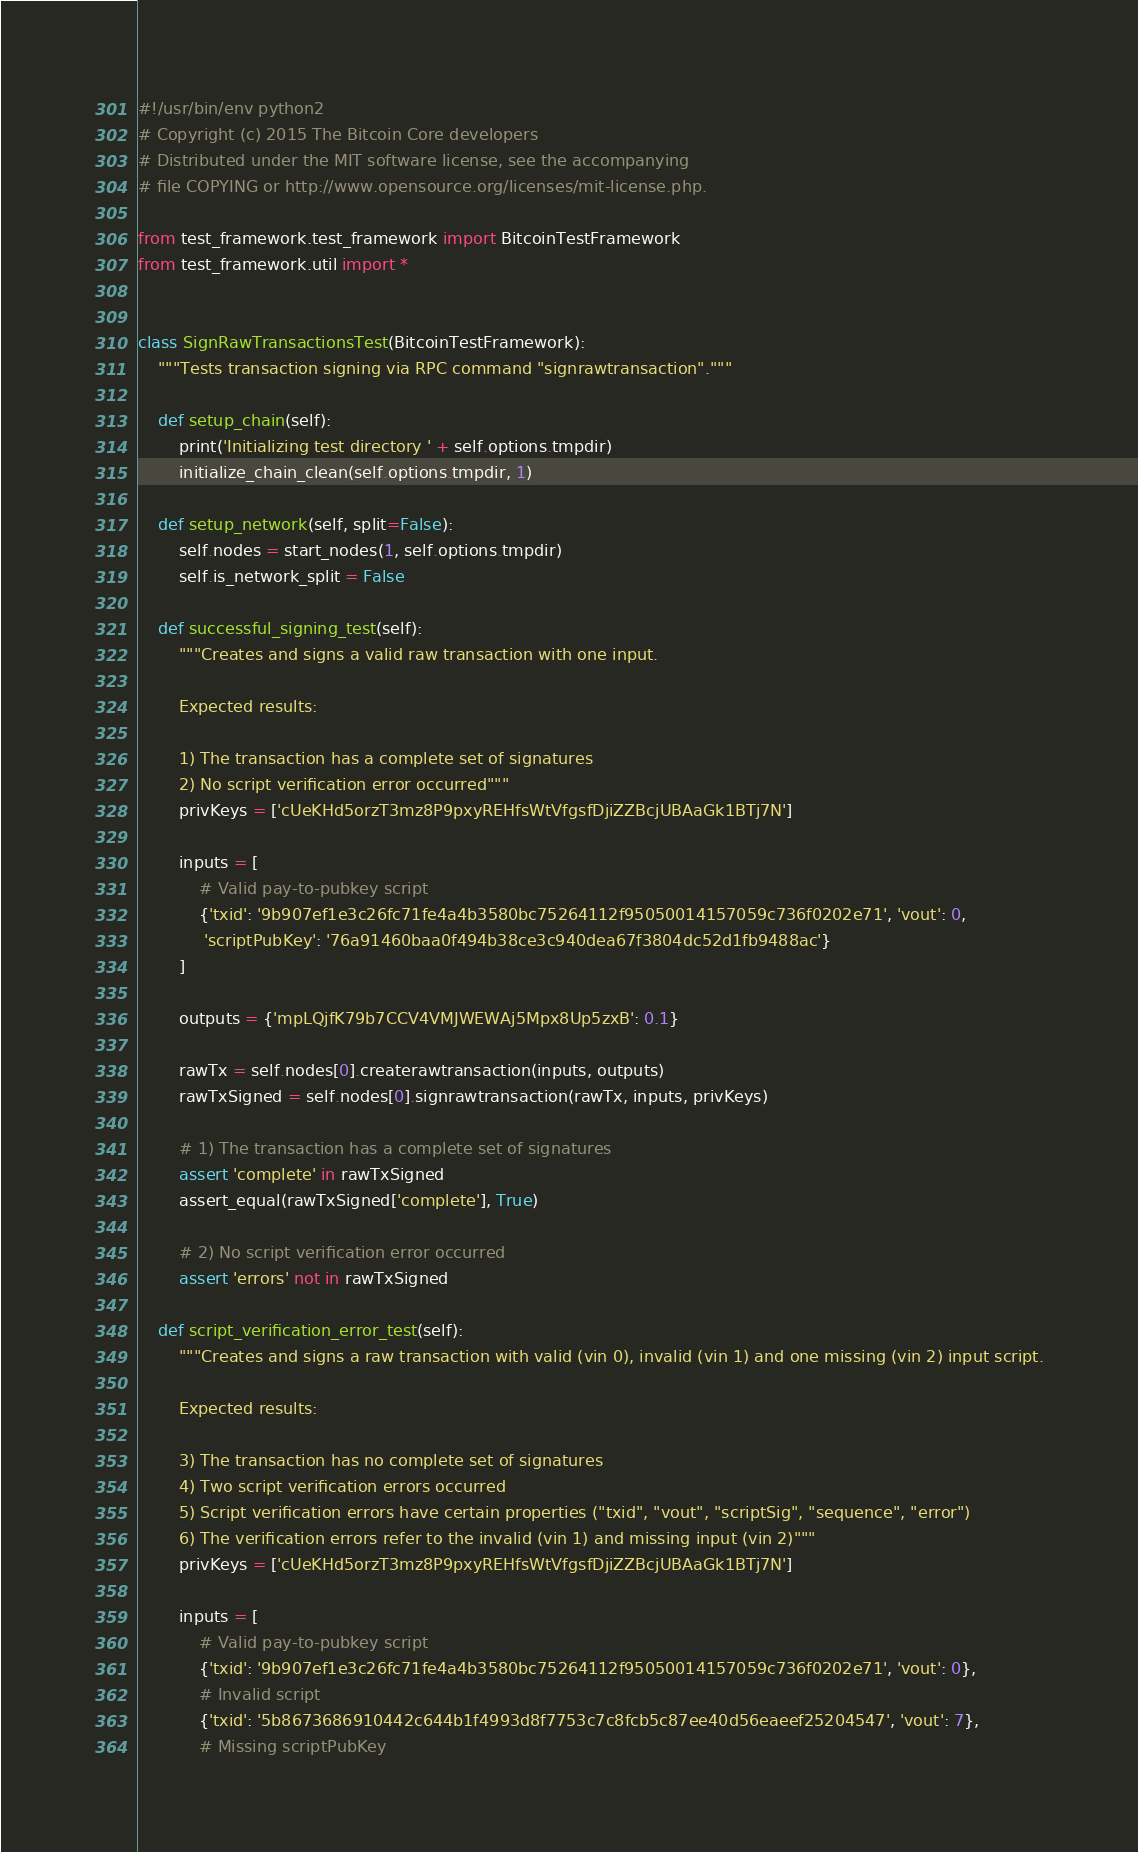Convert code to text. <code><loc_0><loc_0><loc_500><loc_500><_Python_>#!/usr/bin/env python2
# Copyright (c) 2015 The Bitcoin Core developers
# Distributed under the MIT software license, see the accompanying
# file COPYING or http://www.opensource.org/licenses/mit-license.php.

from test_framework.test_framework import BitcoinTestFramework
from test_framework.util import *


class SignRawTransactionsTest(BitcoinTestFramework):
    """Tests transaction signing via RPC command "signrawtransaction"."""

    def setup_chain(self):
        print('Initializing test directory ' + self.options.tmpdir)
        initialize_chain_clean(self.options.tmpdir, 1)

    def setup_network(self, split=False):
        self.nodes = start_nodes(1, self.options.tmpdir)
        self.is_network_split = False

    def successful_signing_test(self):
        """Creates and signs a valid raw transaction with one input.

        Expected results:

        1) The transaction has a complete set of signatures
        2) No script verification error occurred"""
        privKeys = ['cUeKHd5orzT3mz8P9pxyREHfsWtVfgsfDjiZZBcjUBAaGk1BTj7N']

        inputs = [
            # Valid pay-to-pubkey script
            {'txid': '9b907ef1e3c26fc71fe4a4b3580bc75264112f95050014157059c736f0202e71', 'vout': 0,
             'scriptPubKey': '76a91460baa0f494b38ce3c940dea67f3804dc52d1fb9488ac'}
        ]

        outputs = {'mpLQjfK79b7CCV4VMJWEWAj5Mpx8Up5zxB': 0.1}

        rawTx = self.nodes[0].createrawtransaction(inputs, outputs)
        rawTxSigned = self.nodes[0].signrawtransaction(rawTx, inputs, privKeys)

        # 1) The transaction has a complete set of signatures
        assert 'complete' in rawTxSigned
        assert_equal(rawTxSigned['complete'], True)

        # 2) No script verification error occurred
        assert 'errors' not in rawTxSigned

    def script_verification_error_test(self):
        """Creates and signs a raw transaction with valid (vin 0), invalid (vin 1) and one missing (vin 2) input script.

        Expected results:

        3) The transaction has no complete set of signatures
        4) Two script verification errors occurred
        5) Script verification errors have certain properties ("txid", "vout", "scriptSig", "sequence", "error")
        6) The verification errors refer to the invalid (vin 1) and missing input (vin 2)"""
        privKeys = ['cUeKHd5orzT3mz8P9pxyREHfsWtVfgsfDjiZZBcjUBAaGk1BTj7N']

        inputs = [
            # Valid pay-to-pubkey script
            {'txid': '9b907ef1e3c26fc71fe4a4b3580bc75264112f95050014157059c736f0202e71', 'vout': 0},
            # Invalid script
            {'txid': '5b8673686910442c644b1f4993d8f7753c7c8fcb5c87ee40d56eaeef25204547', 'vout': 7},
            # Missing scriptPubKey</code> 